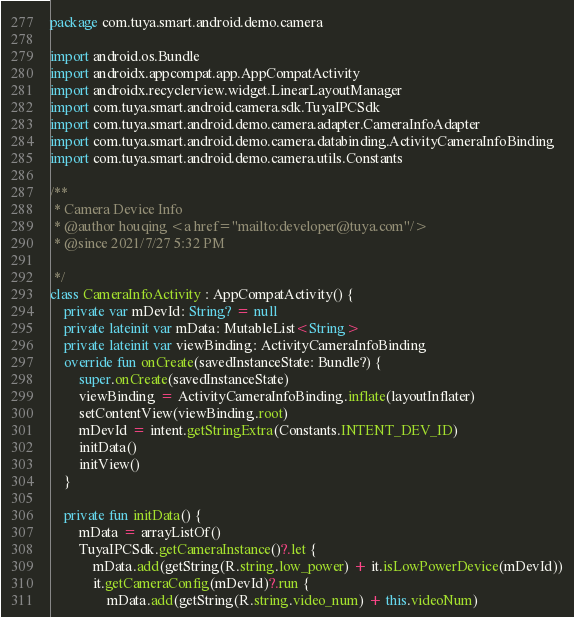Convert code to text. <code><loc_0><loc_0><loc_500><loc_500><_Kotlin_>package com.tuya.smart.android.demo.camera

import android.os.Bundle
import androidx.appcompat.app.AppCompatActivity
import androidx.recyclerview.widget.LinearLayoutManager
import com.tuya.smart.android.camera.sdk.TuyaIPCSdk
import com.tuya.smart.android.demo.camera.adapter.CameraInfoAdapter
import com.tuya.smart.android.demo.camera.databinding.ActivityCameraInfoBinding
import com.tuya.smart.android.demo.camera.utils.Constants

/**
 * Camera Device Info
 * @author houqing <a href="mailto:developer@tuya.com"/>
 * @since 2021/7/27 5:32 PM

 */
class CameraInfoActivity : AppCompatActivity() {
    private var mDevId: String? = null
    private lateinit var mData: MutableList<String>
    private lateinit var viewBinding: ActivityCameraInfoBinding
    override fun onCreate(savedInstanceState: Bundle?) {
        super.onCreate(savedInstanceState)
        viewBinding = ActivityCameraInfoBinding.inflate(layoutInflater)
        setContentView(viewBinding.root)
        mDevId = intent.getStringExtra(Constants.INTENT_DEV_ID)
        initData()
        initView()
    }

    private fun initData() {
        mData = arrayListOf()
        TuyaIPCSdk.getCameraInstance()?.let {
            mData.add(getString(R.string.low_power) + it.isLowPowerDevice(mDevId))
            it.getCameraConfig(mDevId)?.run {
                mData.add(getString(R.string.video_num) + this.videoNum)</code> 